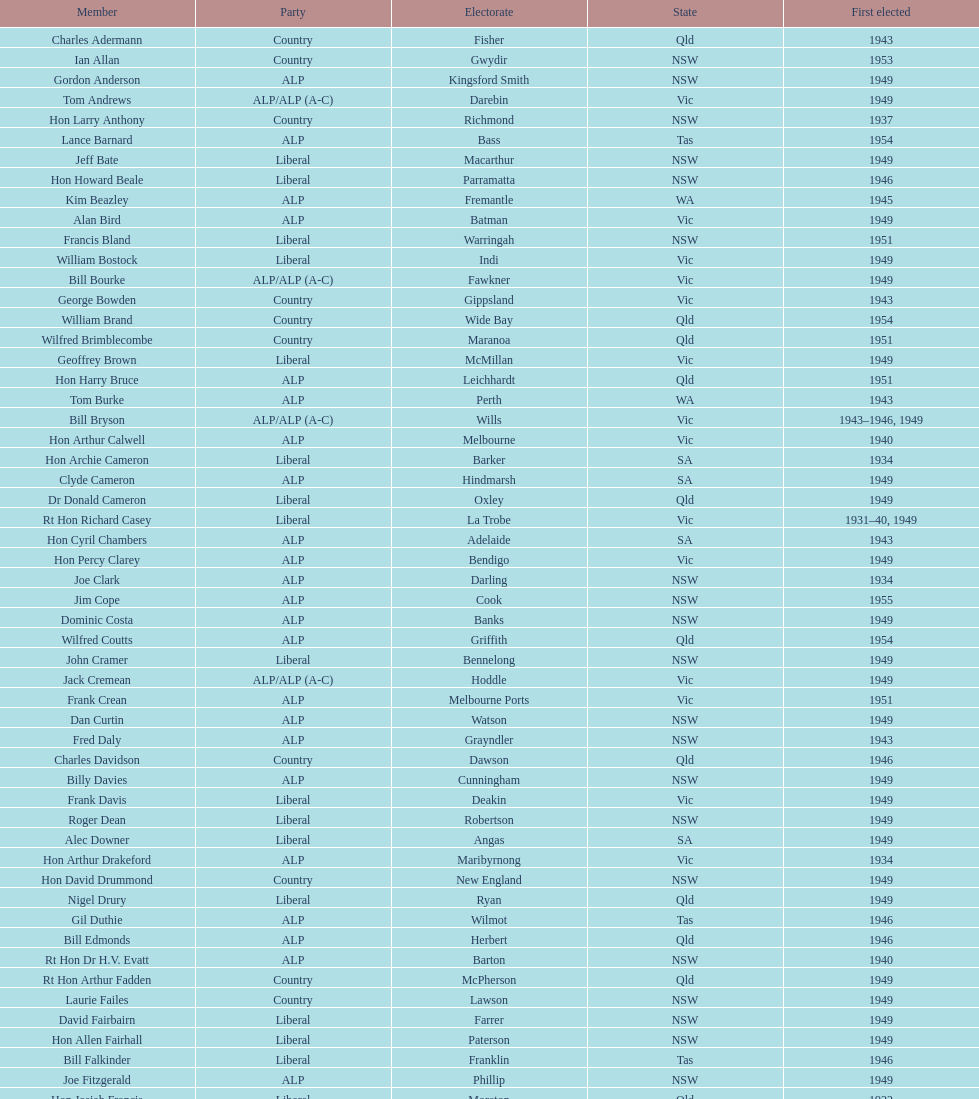When did joe clark initially get elected? 1934. 